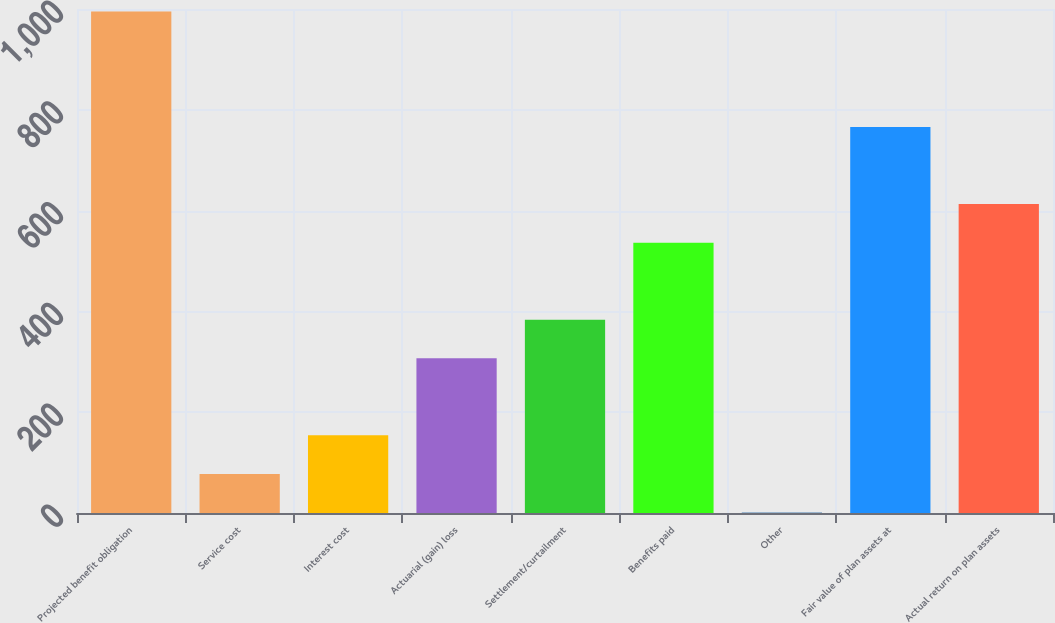Convert chart to OTSL. <chart><loc_0><loc_0><loc_500><loc_500><bar_chart><fcel>Projected benefit obligation<fcel>Service cost<fcel>Interest cost<fcel>Actuarial (gain) loss<fcel>Settlement/curtailment<fcel>Benefits paid<fcel>Other<fcel>Fair value of plan assets at<fcel>Actual return on plan assets<nl><fcel>995.21<fcel>77.57<fcel>154.04<fcel>306.98<fcel>383.45<fcel>536.39<fcel>1.1<fcel>765.8<fcel>612.86<nl></chart> 